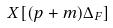Convert formula to latex. <formula><loc_0><loc_0><loc_500><loc_500>X [ ( p + m ) \Delta _ { F } ]</formula> 